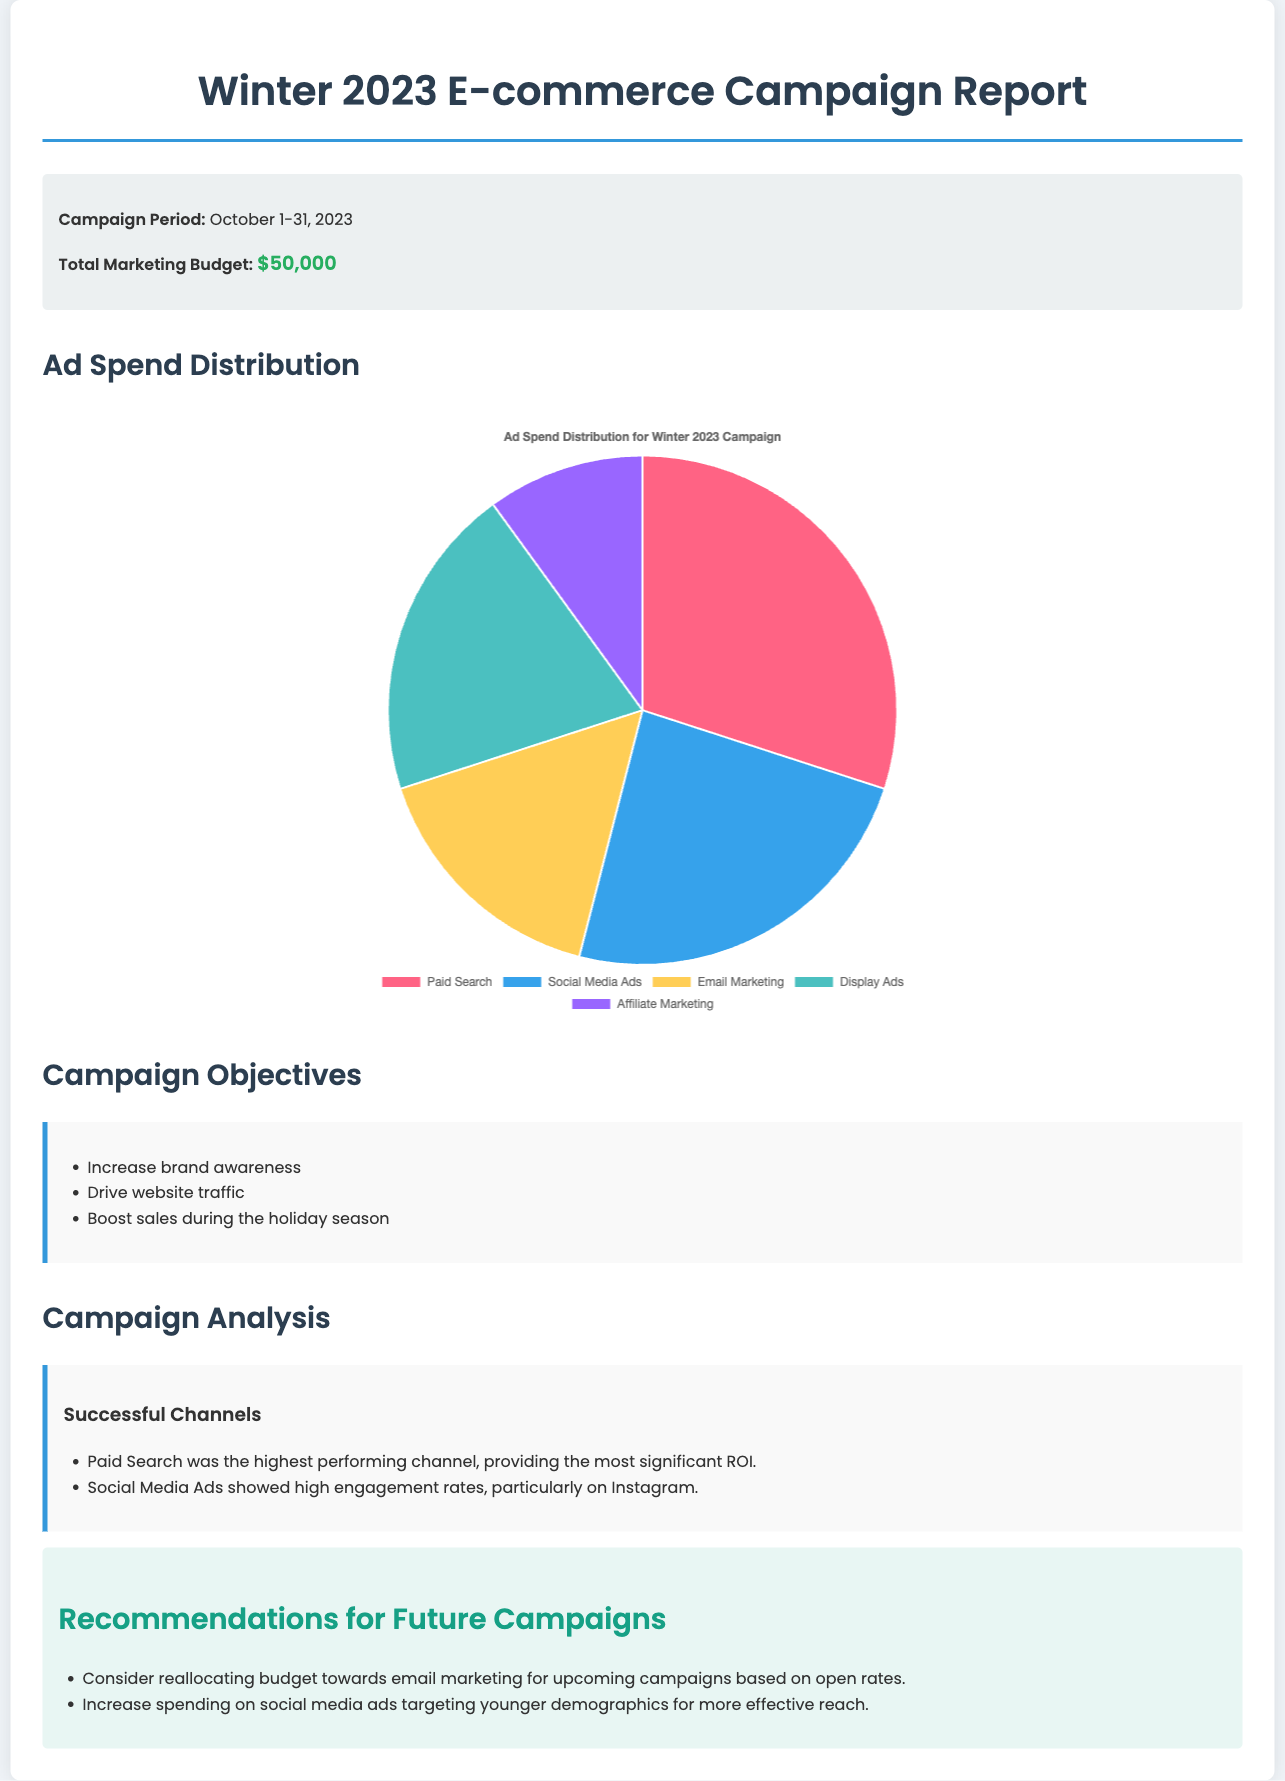What was the total marketing budget? The total marketing budget is stated in the campaign info section of the document.
Answer: $50,000 During what period did the campaign take place? The campaign period is mentioned in the campaign info section.
Answer: October 1-31, 2023 Which channel had the highest ad spend? The ad spend distribution for each channel is shown in the pie chart, where Paid Search had the highest allocation.
Answer: Paid Search What percentage of the total budget was allocated to Social Media Ads? The data for Social Media Ads is provided in the pie chart, allowing for calculation based on total budget; it accounts for $12,000 out of $50,000.
Answer: 24% What are two successful channels mentioned in the analysis? The analysis section lists successful channels based on performance, namely Paid Search and Social Media Ads.
Answer: Paid Search, Social Media Ads What type of report is this document? The document provides insights on financial expenditure in a marketing campaign.
Answer: Financial report What is one recommendation for future campaigns? The recommendations section contains insights for enhancing future strategies, such as reallocating budgets.
Answer: Reallocating budget towards email marketing How is the ad spend distribution presented? The ad spend distribution is visually represented using a pie chart within the document.
Answer: Pie chart 